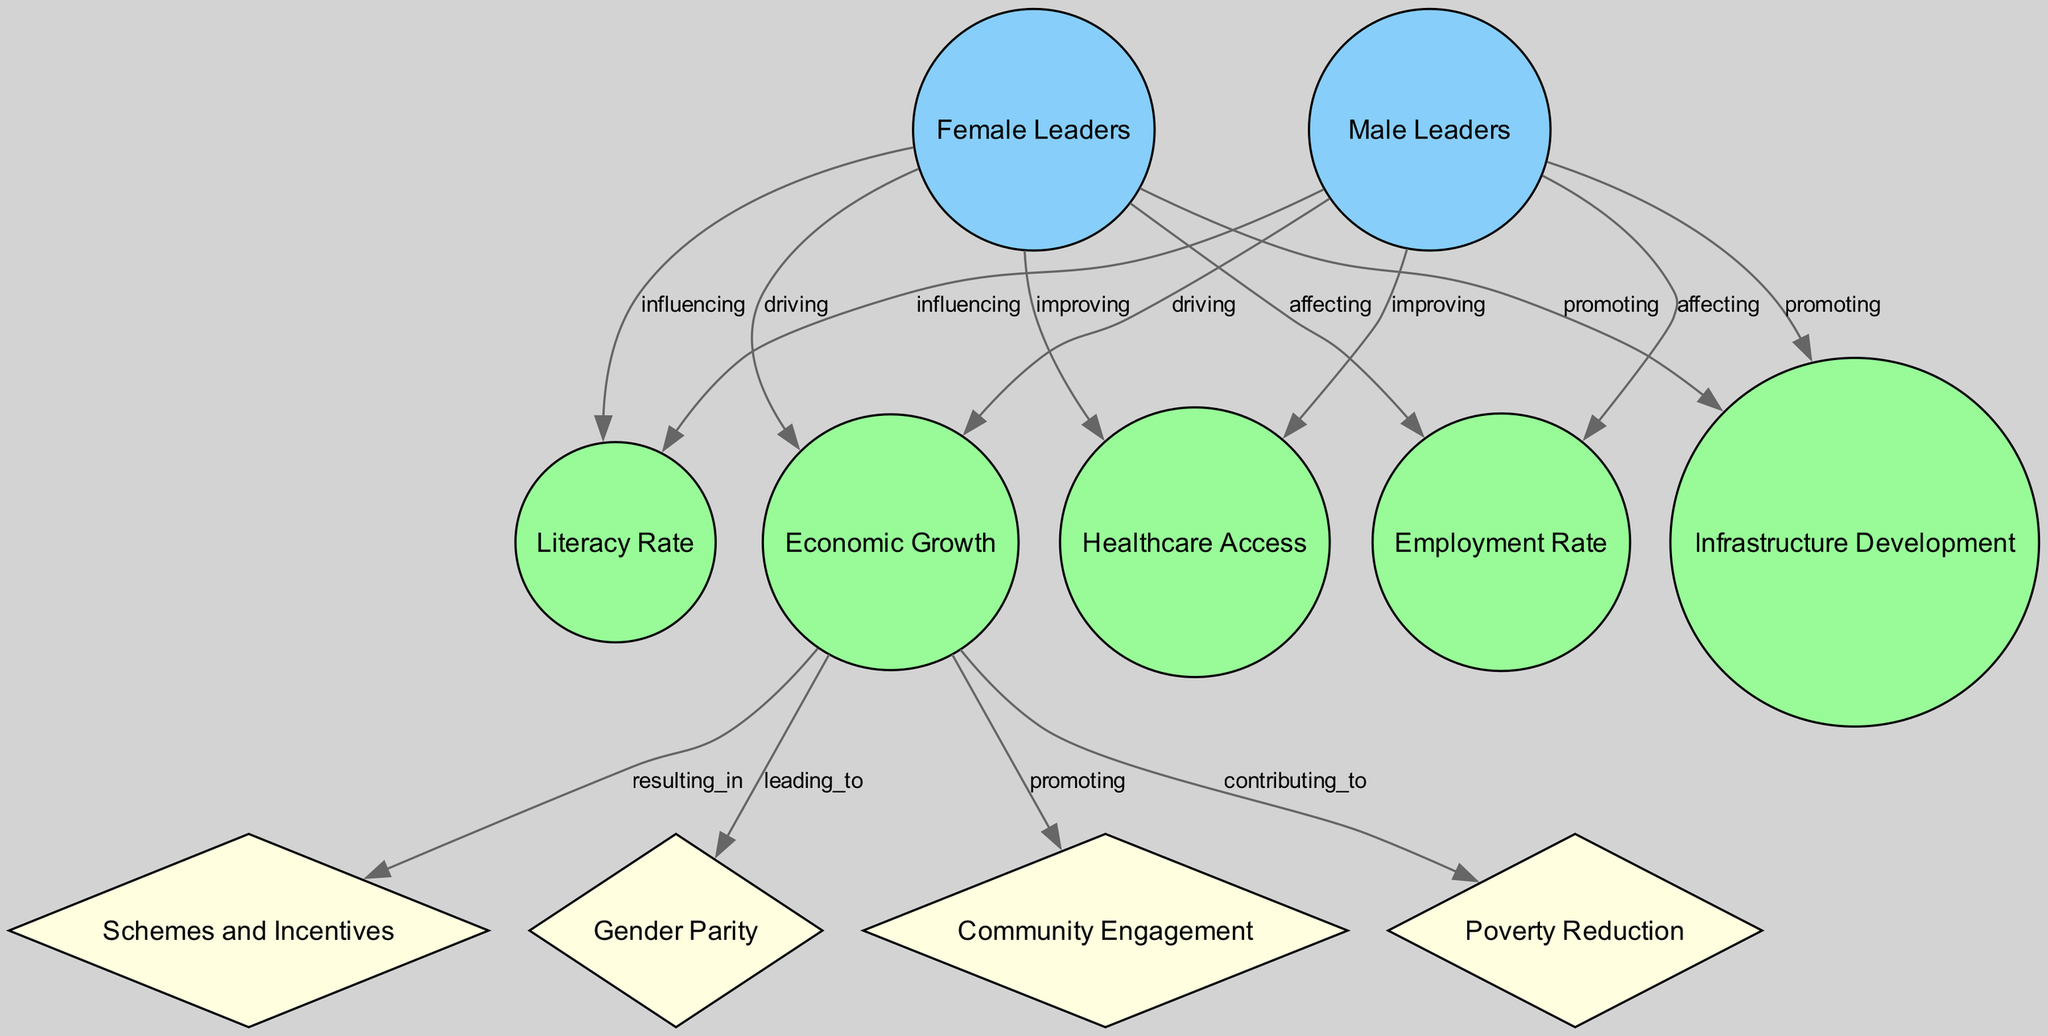What are the two types of leaders depicted in this diagram? The diagram identifies two types of leaders specifically: "Female Leaders" and "Male Leaders" as indicated in the nodes section.
Answer: Female Leaders and Male Leaders How many central nodes are present in the diagram? The diagram displays two central nodes: "Female Leaders" and "Male Leaders." Therefore, the total count is two.
Answer: 2 Which feature is directly influenced by both female and male leaders? The diagram shows that both female and male leaders influence the "Literacy Rate," as illustrated by the respective edges connecting them to this feature.
Answer: Literacy Rate What impact is associated with economic growth? The diagram indicates that "Economic Growth" leads to multiple impacts, specifically including "Schemes and Incentives," "Gender Parity," "Community Engagement," and "Poverty Reduction."
Answer: Schemes and Incentives, Gender Parity, Community Engagement, Poverty Reduction Which type of edge connects leaders to the economic growth node? The edges connecting both types of leaders to the "Economic Growth" node are labeled as "driving," signifying the influence both have on economic growth.
Answer: driving Which node represents healthcare access? In reviewing the diagram, "Healthcare Access" is clearly represented as one of the feature nodes and is colored green, indicating its function in the context of economic growth.
Answer: Healthcare Access How is the relationship between female leaders and infrastructure development characterized? The diagram indicates that female leaders are promoting "Infrastructure Development," which is an edge originating from the "Female Leaders" node to the "Infrastructure Development" node.
Answer: promoting What is the color of the node representing economic growth? The "Economic Growth" node is represented in green, which differentiates it from the central leader nodes and other impact nodes.
Answer: green Which features are shown to be affected by both female and male leaders? Analyzing the connections reveals that "Employment Rate," "Healthcare Access," and "Infrastructure Development" are all affected by both female and male leaders, as evidenced by the edges linking them to the respective nodes.
Answer: Employment Rate, Healthcare Access, Infrastructure Development 